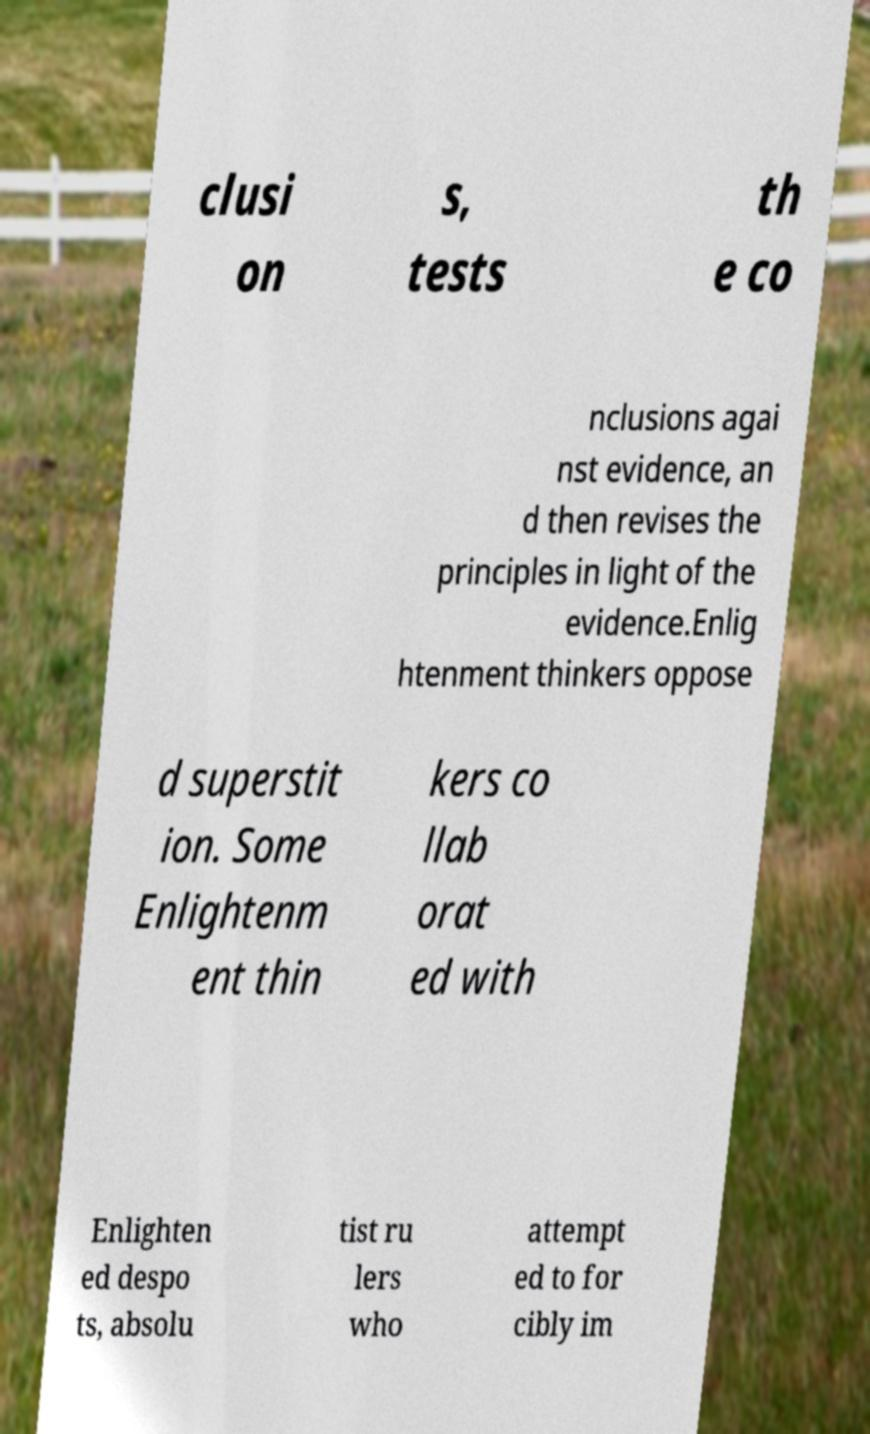There's text embedded in this image that I need extracted. Can you transcribe it verbatim? clusi on s, tests th e co nclusions agai nst evidence, an d then revises the principles in light of the evidence.Enlig htenment thinkers oppose d superstit ion. Some Enlightenm ent thin kers co llab orat ed with Enlighten ed despo ts, absolu tist ru lers who attempt ed to for cibly im 